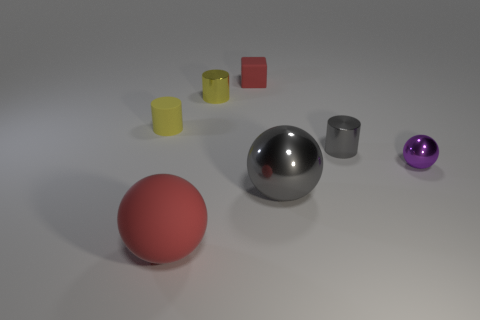Add 3 small red rubber blocks. How many objects exist? 10 Subtract all cubes. How many objects are left? 6 Subtract 0 yellow spheres. How many objects are left? 7 Subtract all tiny red things. Subtract all small blue rubber balls. How many objects are left? 6 Add 6 tiny red matte cubes. How many tiny red matte cubes are left? 7 Add 6 big cyan shiny cylinders. How many big cyan shiny cylinders exist? 6 